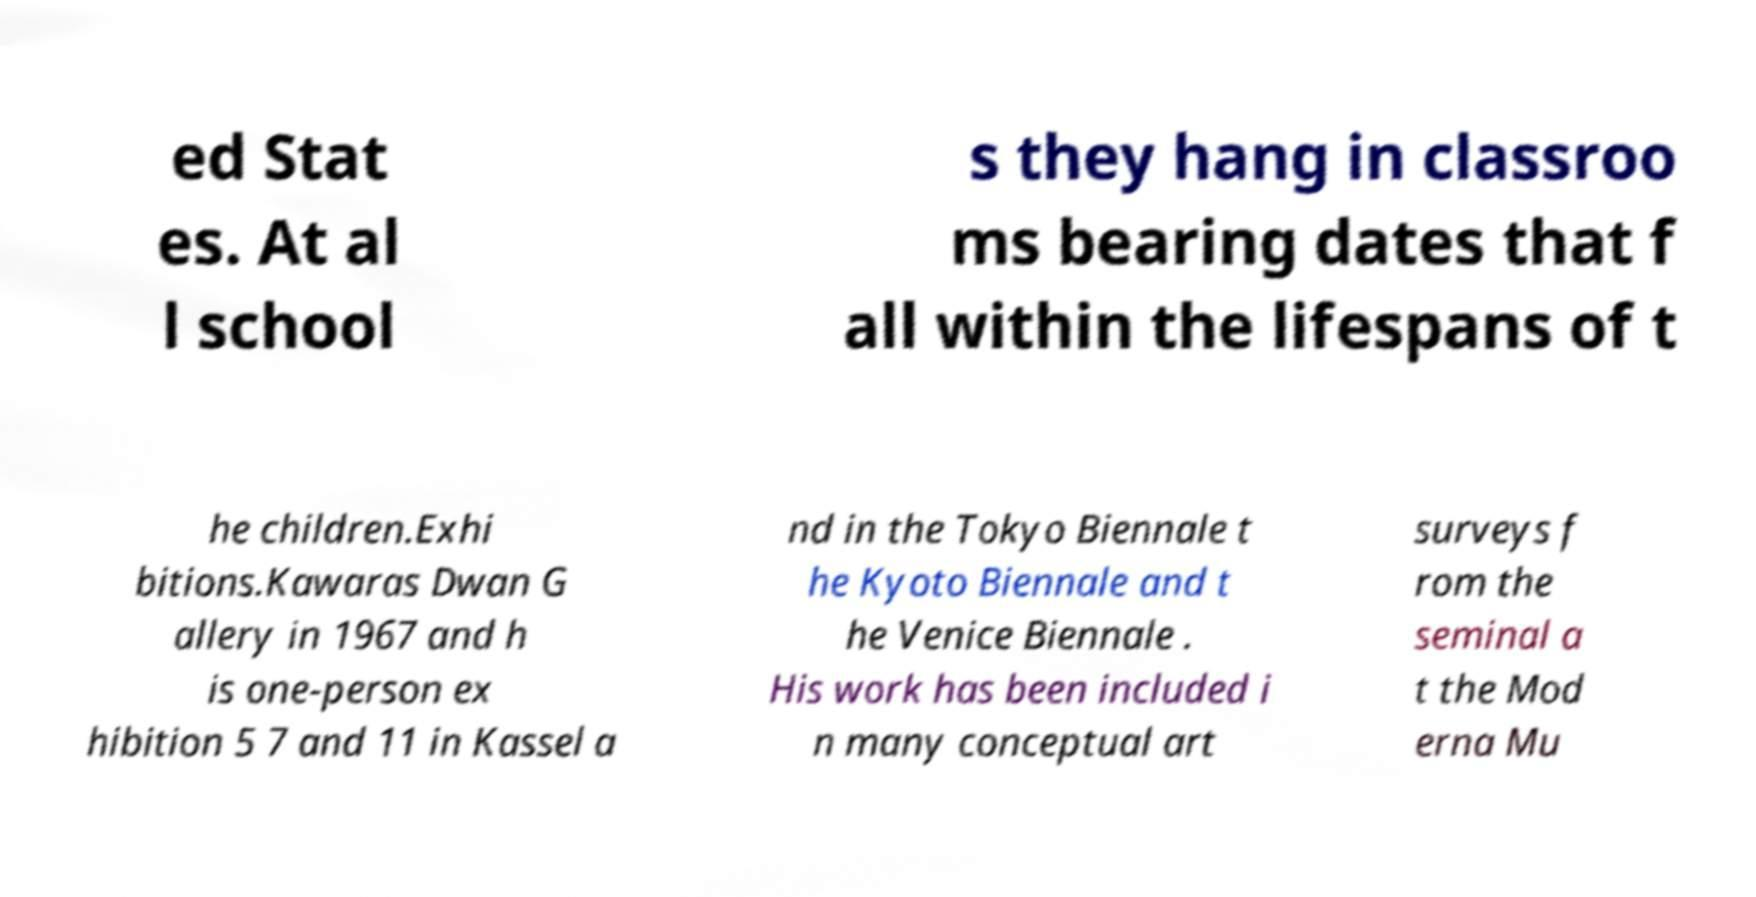Please identify and transcribe the text found in this image. ed Stat es. At al l school s they hang in classroo ms bearing dates that f all within the lifespans of t he children.Exhi bitions.Kawaras Dwan G allery in 1967 and h is one-person ex hibition 5 7 and 11 in Kassel a nd in the Tokyo Biennale t he Kyoto Biennale and t he Venice Biennale . His work has been included i n many conceptual art surveys f rom the seminal a t the Mod erna Mu 